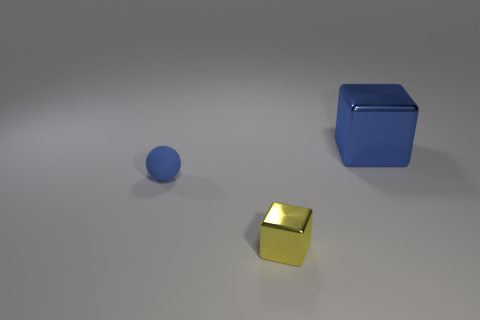Add 3 tiny cyan metallic objects. How many objects exist? 6 Subtract all cubes. How many objects are left? 1 Add 3 small blue matte spheres. How many small blue matte spheres are left? 4 Add 2 purple rubber cylinders. How many purple rubber cylinders exist? 2 Subtract 0 purple blocks. How many objects are left? 3 Subtract all blue spheres. Subtract all small blue rubber objects. How many objects are left? 1 